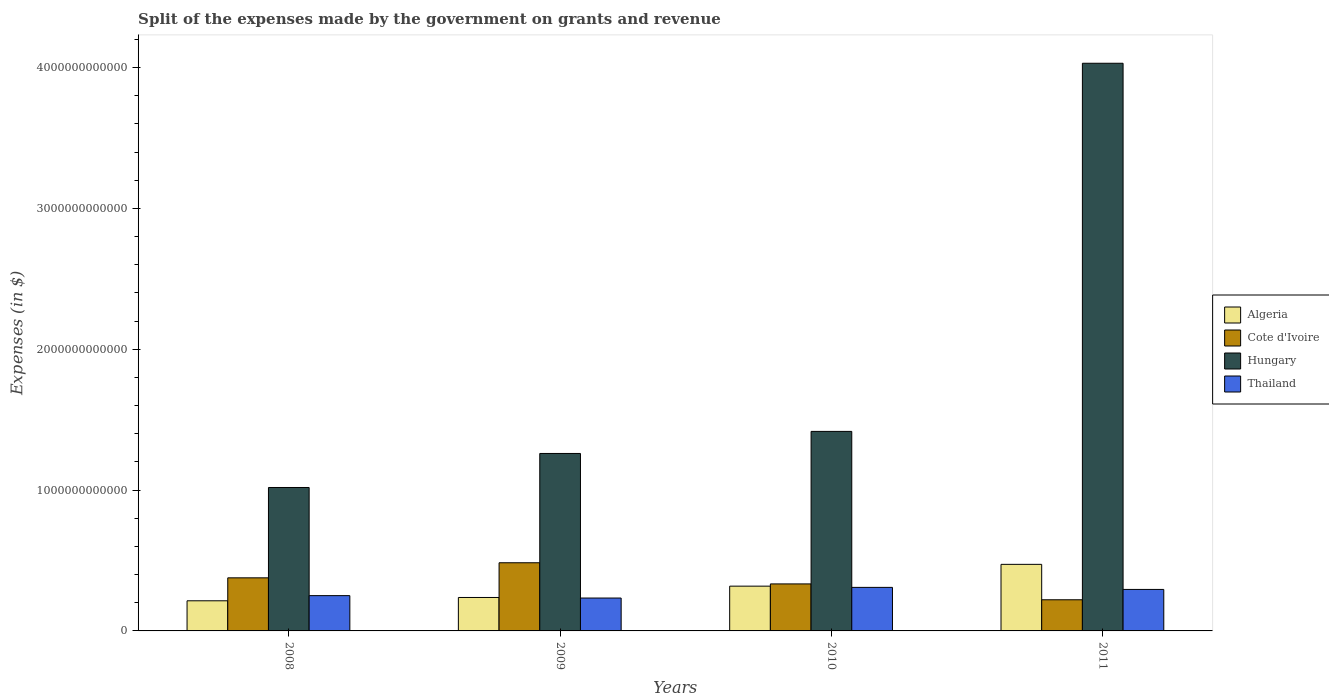How many different coloured bars are there?
Ensure brevity in your answer.  4. How many groups of bars are there?
Make the answer very short. 4. Are the number of bars on each tick of the X-axis equal?
Keep it short and to the point. Yes. How many bars are there on the 2nd tick from the left?
Ensure brevity in your answer.  4. What is the label of the 2nd group of bars from the left?
Make the answer very short. 2009. In how many cases, is the number of bars for a given year not equal to the number of legend labels?
Keep it short and to the point. 0. What is the expenses made by the government on grants and revenue in Thailand in 2010?
Offer a terse response. 3.09e+11. Across all years, what is the maximum expenses made by the government on grants and revenue in Algeria?
Provide a short and direct response. 4.73e+11. Across all years, what is the minimum expenses made by the government on grants and revenue in Cote d'Ivoire?
Provide a succinct answer. 2.21e+11. In which year was the expenses made by the government on grants and revenue in Algeria maximum?
Your answer should be very brief. 2011. In which year was the expenses made by the government on grants and revenue in Thailand minimum?
Provide a succinct answer. 2009. What is the total expenses made by the government on grants and revenue in Algeria in the graph?
Ensure brevity in your answer.  1.24e+12. What is the difference between the expenses made by the government on grants and revenue in Algeria in 2010 and that in 2011?
Your answer should be compact. -1.55e+11. What is the difference between the expenses made by the government on grants and revenue in Cote d'Ivoire in 2008 and the expenses made by the government on grants and revenue in Thailand in 2010?
Provide a succinct answer. 6.78e+1. What is the average expenses made by the government on grants and revenue in Thailand per year?
Provide a succinct answer. 2.72e+11. In the year 2008, what is the difference between the expenses made by the government on grants and revenue in Algeria and expenses made by the government on grants and revenue in Hungary?
Give a very brief answer. -8.04e+11. What is the ratio of the expenses made by the government on grants and revenue in Cote d'Ivoire in 2009 to that in 2011?
Keep it short and to the point. 2.19. Is the expenses made by the government on grants and revenue in Hungary in 2010 less than that in 2011?
Offer a terse response. Yes. Is the difference between the expenses made by the government on grants and revenue in Algeria in 2009 and 2011 greater than the difference between the expenses made by the government on grants and revenue in Hungary in 2009 and 2011?
Ensure brevity in your answer.  Yes. What is the difference between the highest and the second highest expenses made by the government on grants and revenue in Thailand?
Make the answer very short. 1.45e+1. What is the difference between the highest and the lowest expenses made by the government on grants and revenue in Algeria?
Give a very brief answer. 2.59e+11. Is the sum of the expenses made by the government on grants and revenue in Algeria in 2008 and 2010 greater than the maximum expenses made by the government on grants and revenue in Cote d'Ivoire across all years?
Your response must be concise. Yes. Is it the case that in every year, the sum of the expenses made by the government on grants and revenue in Thailand and expenses made by the government on grants and revenue in Hungary is greater than the sum of expenses made by the government on grants and revenue in Algeria and expenses made by the government on grants and revenue in Cote d'Ivoire?
Your answer should be very brief. No. What does the 2nd bar from the left in 2010 represents?
Offer a very short reply. Cote d'Ivoire. What does the 2nd bar from the right in 2009 represents?
Provide a succinct answer. Hungary. Is it the case that in every year, the sum of the expenses made by the government on grants and revenue in Algeria and expenses made by the government on grants and revenue in Cote d'Ivoire is greater than the expenses made by the government on grants and revenue in Thailand?
Provide a short and direct response. Yes. What is the difference between two consecutive major ticks on the Y-axis?
Make the answer very short. 1.00e+12. Are the values on the major ticks of Y-axis written in scientific E-notation?
Offer a terse response. No. Does the graph contain any zero values?
Ensure brevity in your answer.  No. Does the graph contain grids?
Ensure brevity in your answer.  No. How many legend labels are there?
Provide a short and direct response. 4. What is the title of the graph?
Offer a very short reply. Split of the expenses made by the government on grants and revenue. What is the label or title of the Y-axis?
Provide a succinct answer. Expenses (in $). What is the Expenses (in $) of Algeria in 2008?
Your answer should be compact. 2.14e+11. What is the Expenses (in $) in Cote d'Ivoire in 2008?
Make the answer very short. 3.77e+11. What is the Expenses (in $) in Hungary in 2008?
Give a very brief answer. 1.02e+12. What is the Expenses (in $) in Thailand in 2008?
Provide a short and direct response. 2.50e+11. What is the Expenses (in $) of Algeria in 2009?
Offer a very short reply. 2.37e+11. What is the Expenses (in $) in Cote d'Ivoire in 2009?
Ensure brevity in your answer.  4.84e+11. What is the Expenses (in $) of Hungary in 2009?
Offer a terse response. 1.26e+12. What is the Expenses (in $) of Thailand in 2009?
Give a very brief answer. 2.33e+11. What is the Expenses (in $) of Algeria in 2010?
Your answer should be very brief. 3.18e+11. What is the Expenses (in $) of Cote d'Ivoire in 2010?
Your answer should be compact. 3.34e+11. What is the Expenses (in $) of Hungary in 2010?
Provide a succinct answer. 1.42e+12. What is the Expenses (in $) of Thailand in 2010?
Provide a succinct answer. 3.09e+11. What is the Expenses (in $) in Algeria in 2011?
Ensure brevity in your answer.  4.73e+11. What is the Expenses (in $) in Cote d'Ivoire in 2011?
Make the answer very short. 2.21e+11. What is the Expenses (in $) in Hungary in 2011?
Provide a short and direct response. 4.03e+12. What is the Expenses (in $) of Thailand in 2011?
Your answer should be compact. 2.95e+11. Across all years, what is the maximum Expenses (in $) in Algeria?
Provide a succinct answer. 4.73e+11. Across all years, what is the maximum Expenses (in $) of Cote d'Ivoire?
Give a very brief answer. 4.84e+11. Across all years, what is the maximum Expenses (in $) of Hungary?
Provide a succinct answer. 4.03e+12. Across all years, what is the maximum Expenses (in $) in Thailand?
Ensure brevity in your answer.  3.09e+11. Across all years, what is the minimum Expenses (in $) of Algeria?
Your answer should be compact. 2.14e+11. Across all years, what is the minimum Expenses (in $) in Cote d'Ivoire?
Keep it short and to the point. 2.21e+11. Across all years, what is the minimum Expenses (in $) of Hungary?
Your answer should be very brief. 1.02e+12. Across all years, what is the minimum Expenses (in $) in Thailand?
Offer a very short reply. 2.33e+11. What is the total Expenses (in $) of Algeria in the graph?
Give a very brief answer. 1.24e+12. What is the total Expenses (in $) in Cote d'Ivoire in the graph?
Ensure brevity in your answer.  1.42e+12. What is the total Expenses (in $) of Hungary in the graph?
Keep it short and to the point. 7.72e+12. What is the total Expenses (in $) of Thailand in the graph?
Your answer should be compact. 1.09e+12. What is the difference between the Expenses (in $) of Algeria in 2008 and that in 2009?
Provide a short and direct response. -2.36e+1. What is the difference between the Expenses (in $) in Cote d'Ivoire in 2008 and that in 2009?
Your answer should be compact. -1.07e+11. What is the difference between the Expenses (in $) of Hungary in 2008 and that in 2009?
Offer a terse response. -2.42e+11. What is the difference between the Expenses (in $) of Thailand in 2008 and that in 2009?
Ensure brevity in your answer.  1.71e+1. What is the difference between the Expenses (in $) in Algeria in 2008 and that in 2010?
Make the answer very short. -1.04e+11. What is the difference between the Expenses (in $) of Cote d'Ivoire in 2008 and that in 2010?
Make the answer very short. 4.31e+1. What is the difference between the Expenses (in $) in Hungary in 2008 and that in 2010?
Your answer should be very brief. -3.98e+11. What is the difference between the Expenses (in $) of Thailand in 2008 and that in 2010?
Your answer should be very brief. -5.86e+1. What is the difference between the Expenses (in $) of Algeria in 2008 and that in 2011?
Offer a very short reply. -2.59e+11. What is the difference between the Expenses (in $) of Cote d'Ivoire in 2008 and that in 2011?
Your answer should be very brief. 1.56e+11. What is the difference between the Expenses (in $) in Hungary in 2008 and that in 2011?
Your answer should be compact. -3.01e+12. What is the difference between the Expenses (in $) in Thailand in 2008 and that in 2011?
Ensure brevity in your answer.  -4.41e+1. What is the difference between the Expenses (in $) of Algeria in 2009 and that in 2010?
Give a very brief answer. -8.04e+1. What is the difference between the Expenses (in $) in Cote d'Ivoire in 2009 and that in 2010?
Your answer should be very brief. 1.50e+11. What is the difference between the Expenses (in $) of Hungary in 2009 and that in 2010?
Keep it short and to the point. -1.57e+11. What is the difference between the Expenses (in $) in Thailand in 2009 and that in 2010?
Your response must be concise. -7.57e+1. What is the difference between the Expenses (in $) of Algeria in 2009 and that in 2011?
Offer a very short reply. -2.35e+11. What is the difference between the Expenses (in $) of Cote d'Ivoire in 2009 and that in 2011?
Offer a terse response. 2.63e+11. What is the difference between the Expenses (in $) of Hungary in 2009 and that in 2011?
Make the answer very short. -2.77e+12. What is the difference between the Expenses (in $) of Thailand in 2009 and that in 2011?
Your response must be concise. -6.11e+1. What is the difference between the Expenses (in $) of Algeria in 2010 and that in 2011?
Keep it short and to the point. -1.55e+11. What is the difference between the Expenses (in $) of Cote d'Ivoire in 2010 and that in 2011?
Give a very brief answer. 1.13e+11. What is the difference between the Expenses (in $) in Hungary in 2010 and that in 2011?
Provide a short and direct response. -2.61e+12. What is the difference between the Expenses (in $) of Thailand in 2010 and that in 2011?
Give a very brief answer. 1.45e+1. What is the difference between the Expenses (in $) in Algeria in 2008 and the Expenses (in $) in Cote d'Ivoire in 2009?
Give a very brief answer. -2.70e+11. What is the difference between the Expenses (in $) of Algeria in 2008 and the Expenses (in $) of Hungary in 2009?
Your answer should be compact. -1.05e+12. What is the difference between the Expenses (in $) in Algeria in 2008 and the Expenses (in $) in Thailand in 2009?
Your answer should be very brief. -1.95e+1. What is the difference between the Expenses (in $) of Cote d'Ivoire in 2008 and the Expenses (in $) of Hungary in 2009?
Your response must be concise. -8.83e+11. What is the difference between the Expenses (in $) in Cote d'Ivoire in 2008 and the Expenses (in $) in Thailand in 2009?
Provide a short and direct response. 1.43e+11. What is the difference between the Expenses (in $) in Hungary in 2008 and the Expenses (in $) in Thailand in 2009?
Make the answer very short. 7.85e+11. What is the difference between the Expenses (in $) of Algeria in 2008 and the Expenses (in $) of Cote d'Ivoire in 2010?
Your answer should be compact. -1.20e+11. What is the difference between the Expenses (in $) of Algeria in 2008 and the Expenses (in $) of Hungary in 2010?
Ensure brevity in your answer.  -1.20e+12. What is the difference between the Expenses (in $) in Algeria in 2008 and the Expenses (in $) in Thailand in 2010?
Offer a terse response. -9.52e+1. What is the difference between the Expenses (in $) of Cote d'Ivoire in 2008 and the Expenses (in $) of Hungary in 2010?
Offer a very short reply. -1.04e+12. What is the difference between the Expenses (in $) of Cote d'Ivoire in 2008 and the Expenses (in $) of Thailand in 2010?
Ensure brevity in your answer.  6.78e+1. What is the difference between the Expenses (in $) in Hungary in 2008 and the Expenses (in $) in Thailand in 2010?
Offer a terse response. 7.09e+11. What is the difference between the Expenses (in $) of Algeria in 2008 and the Expenses (in $) of Cote d'Ivoire in 2011?
Your answer should be compact. -7.29e+09. What is the difference between the Expenses (in $) in Algeria in 2008 and the Expenses (in $) in Hungary in 2011?
Give a very brief answer. -3.82e+12. What is the difference between the Expenses (in $) of Algeria in 2008 and the Expenses (in $) of Thailand in 2011?
Ensure brevity in your answer.  -8.07e+1. What is the difference between the Expenses (in $) in Cote d'Ivoire in 2008 and the Expenses (in $) in Hungary in 2011?
Ensure brevity in your answer.  -3.65e+12. What is the difference between the Expenses (in $) in Cote d'Ivoire in 2008 and the Expenses (in $) in Thailand in 2011?
Make the answer very short. 8.23e+1. What is the difference between the Expenses (in $) of Hungary in 2008 and the Expenses (in $) of Thailand in 2011?
Ensure brevity in your answer.  7.24e+11. What is the difference between the Expenses (in $) in Algeria in 2009 and the Expenses (in $) in Cote d'Ivoire in 2010?
Offer a very short reply. -9.63e+1. What is the difference between the Expenses (in $) of Algeria in 2009 and the Expenses (in $) of Hungary in 2010?
Your answer should be compact. -1.18e+12. What is the difference between the Expenses (in $) in Algeria in 2009 and the Expenses (in $) in Thailand in 2010?
Provide a short and direct response. -7.16e+1. What is the difference between the Expenses (in $) in Cote d'Ivoire in 2009 and the Expenses (in $) in Hungary in 2010?
Offer a terse response. -9.33e+11. What is the difference between the Expenses (in $) of Cote d'Ivoire in 2009 and the Expenses (in $) of Thailand in 2010?
Your answer should be very brief. 1.75e+11. What is the difference between the Expenses (in $) in Hungary in 2009 and the Expenses (in $) in Thailand in 2010?
Your answer should be very brief. 9.51e+11. What is the difference between the Expenses (in $) in Algeria in 2009 and the Expenses (in $) in Cote d'Ivoire in 2011?
Your response must be concise. 1.63e+1. What is the difference between the Expenses (in $) of Algeria in 2009 and the Expenses (in $) of Hungary in 2011?
Your answer should be compact. -3.79e+12. What is the difference between the Expenses (in $) in Algeria in 2009 and the Expenses (in $) in Thailand in 2011?
Provide a succinct answer. -5.71e+1. What is the difference between the Expenses (in $) in Cote d'Ivoire in 2009 and the Expenses (in $) in Hungary in 2011?
Keep it short and to the point. -3.55e+12. What is the difference between the Expenses (in $) in Cote d'Ivoire in 2009 and the Expenses (in $) in Thailand in 2011?
Your response must be concise. 1.89e+11. What is the difference between the Expenses (in $) in Hungary in 2009 and the Expenses (in $) in Thailand in 2011?
Make the answer very short. 9.65e+11. What is the difference between the Expenses (in $) in Algeria in 2010 and the Expenses (in $) in Cote d'Ivoire in 2011?
Your answer should be very brief. 9.67e+1. What is the difference between the Expenses (in $) in Algeria in 2010 and the Expenses (in $) in Hungary in 2011?
Provide a succinct answer. -3.71e+12. What is the difference between the Expenses (in $) in Algeria in 2010 and the Expenses (in $) in Thailand in 2011?
Offer a terse response. 2.33e+1. What is the difference between the Expenses (in $) in Cote d'Ivoire in 2010 and the Expenses (in $) in Hungary in 2011?
Provide a succinct answer. -3.70e+12. What is the difference between the Expenses (in $) in Cote d'Ivoire in 2010 and the Expenses (in $) in Thailand in 2011?
Keep it short and to the point. 3.92e+1. What is the difference between the Expenses (in $) in Hungary in 2010 and the Expenses (in $) in Thailand in 2011?
Keep it short and to the point. 1.12e+12. What is the average Expenses (in $) of Algeria per year?
Give a very brief answer. 3.10e+11. What is the average Expenses (in $) in Cote d'Ivoire per year?
Offer a terse response. 3.54e+11. What is the average Expenses (in $) in Hungary per year?
Make the answer very short. 1.93e+12. What is the average Expenses (in $) in Thailand per year?
Offer a very short reply. 2.72e+11. In the year 2008, what is the difference between the Expenses (in $) of Algeria and Expenses (in $) of Cote d'Ivoire?
Offer a terse response. -1.63e+11. In the year 2008, what is the difference between the Expenses (in $) in Algeria and Expenses (in $) in Hungary?
Offer a terse response. -8.04e+11. In the year 2008, what is the difference between the Expenses (in $) of Algeria and Expenses (in $) of Thailand?
Make the answer very short. -3.66e+1. In the year 2008, what is the difference between the Expenses (in $) in Cote d'Ivoire and Expenses (in $) in Hungary?
Ensure brevity in your answer.  -6.41e+11. In the year 2008, what is the difference between the Expenses (in $) in Cote d'Ivoire and Expenses (in $) in Thailand?
Provide a succinct answer. 1.26e+11. In the year 2008, what is the difference between the Expenses (in $) of Hungary and Expenses (in $) of Thailand?
Your response must be concise. 7.68e+11. In the year 2009, what is the difference between the Expenses (in $) of Algeria and Expenses (in $) of Cote d'Ivoire?
Provide a short and direct response. -2.47e+11. In the year 2009, what is the difference between the Expenses (in $) of Algeria and Expenses (in $) of Hungary?
Keep it short and to the point. -1.02e+12. In the year 2009, what is the difference between the Expenses (in $) in Algeria and Expenses (in $) in Thailand?
Keep it short and to the point. 4.04e+09. In the year 2009, what is the difference between the Expenses (in $) of Cote d'Ivoire and Expenses (in $) of Hungary?
Offer a terse response. -7.76e+11. In the year 2009, what is the difference between the Expenses (in $) in Cote d'Ivoire and Expenses (in $) in Thailand?
Your answer should be very brief. 2.51e+11. In the year 2009, what is the difference between the Expenses (in $) in Hungary and Expenses (in $) in Thailand?
Give a very brief answer. 1.03e+12. In the year 2010, what is the difference between the Expenses (in $) in Algeria and Expenses (in $) in Cote d'Ivoire?
Provide a short and direct response. -1.59e+1. In the year 2010, what is the difference between the Expenses (in $) of Algeria and Expenses (in $) of Hungary?
Provide a succinct answer. -1.10e+12. In the year 2010, what is the difference between the Expenses (in $) of Algeria and Expenses (in $) of Thailand?
Provide a short and direct response. 8.81e+09. In the year 2010, what is the difference between the Expenses (in $) of Cote d'Ivoire and Expenses (in $) of Hungary?
Keep it short and to the point. -1.08e+12. In the year 2010, what is the difference between the Expenses (in $) in Cote d'Ivoire and Expenses (in $) in Thailand?
Offer a terse response. 2.47e+1. In the year 2010, what is the difference between the Expenses (in $) in Hungary and Expenses (in $) in Thailand?
Offer a very short reply. 1.11e+12. In the year 2011, what is the difference between the Expenses (in $) in Algeria and Expenses (in $) in Cote d'Ivoire?
Your response must be concise. 2.51e+11. In the year 2011, what is the difference between the Expenses (in $) of Algeria and Expenses (in $) of Hungary?
Ensure brevity in your answer.  -3.56e+12. In the year 2011, what is the difference between the Expenses (in $) of Algeria and Expenses (in $) of Thailand?
Offer a very short reply. 1.78e+11. In the year 2011, what is the difference between the Expenses (in $) in Cote d'Ivoire and Expenses (in $) in Hungary?
Your response must be concise. -3.81e+12. In the year 2011, what is the difference between the Expenses (in $) of Cote d'Ivoire and Expenses (in $) of Thailand?
Your response must be concise. -7.34e+1. In the year 2011, what is the difference between the Expenses (in $) in Hungary and Expenses (in $) in Thailand?
Provide a succinct answer. 3.74e+12. What is the ratio of the Expenses (in $) in Algeria in 2008 to that in 2009?
Offer a terse response. 0.9. What is the ratio of the Expenses (in $) in Cote d'Ivoire in 2008 to that in 2009?
Keep it short and to the point. 0.78. What is the ratio of the Expenses (in $) in Hungary in 2008 to that in 2009?
Provide a succinct answer. 0.81. What is the ratio of the Expenses (in $) in Thailand in 2008 to that in 2009?
Keep it short and to the point. 1.07. What is the ratio of the Expenses (in $) in Algeria in 2008 to that in 2010?
Provide a succinct answer. 0.67. What is the ratio of the Expenses (in $) of Cote d'Ivoire in 2008 to that in 2010?
Your answer should be very brief. 1.13. What is the ratio of the Expenses (in $) in Hungary in 2008 to that in 2010?
Your response must be concise. 0.72. What is the ratio of the Expenses (in $) of Thailand in 2008 to that in 2010?
Provide a short and direct response. 0.81. What is the ratio of the Expenses (in $) in Algeria in 2008 to that in 2011?
Keep it short and to the point. 0.45. What is the ratio of the Expenses (in $) in Cote d'Ivoire in 2008 to that in 2011?
Offer a terse response. 1.7. What is the ratio of the Expenses (in $) of Hungary in 2008 to that in 2011?
Offer a very short reply. 0.25. What is the ratio of the Expenses (in $) of Thailand in 2008 to that in 2011?
Provide a short and direct response. 0.85. What is the ratio of the Expenses (in $) in Algeria in 2009 to that in 2010?
Offer a very short reply. 0.75. What is the ratio of the Expenses (in $) of Cote d'Ivoire in 2009 to that in 2010?
Make the answer very short. 1.45. What is the ratio of the Expenses (in $) in Hungary in 2009 to that in 2010?
Your response must be concise. 0.89. What is the ratio of the Expenses (in $) in Thailand in 2009 to that in 2010?
Give a very brief answer. 0.76. What is the ratio of the Expenses (in $) of Algeria in 2009 to that in 2011?
Your response must be concise. 0.5. What is the ratio of the Expenses (in $) in Cote d'Ivoire in 2009 to that in 2011?
Provide a succinct answer. 2.19. What is the ratio of the Expenses (in $) in Hungary in 2009 to that in 2011?
Your response must be concise. 0.31. What is the ratio of the Expenses (in $) in Thailand in 2009 to that in 2011?
Offer a very short reply. 0.79. What is the ratio of the Expenses (in $) of Algeria in 2010 to that in 2011?
Your answer should be compact. 0.67. What is the ratio of the Expenses (in $) of Cote d'Ivoire in 2010 to that in 2011?
Your response must be concise. 1.51. What is the ratio of the Expenses (in $) of Hungary in 2010 to that in 2011?
Provide a succinct answer. 0.35. What is the ratio of the Expenses (in $) in Thailand in 2010 to that in 2011?
Your response must be concise. 1.05. What is the difference between the highest and the second highest Expenses (in $) in Algeria?
Provide a short and direct response. 1.55e+11. What is the difference between the highest and the second highest Expenses (in $) in Cote d'Ivoire?
Give a very brief answer. 1.07e+11. What is the difference between the highest and the second highest Expenses (in $) of Hungary?
Offer a very short reply. 2.61e+12. What is the difference between the highest and the second highest Expenses (in $) of Thailand?
Your answer should be very brief. 1.45e+1. What is the difference between the highest and the lowest Expenses (in $) in Algeria?
Provide a succinct answer. 2.59e+11. What is the difference between the highest and the lowest Expenses (in $) in Cote d'Ivoire?
Make the answer very short. 2.63e+11. What is the difference between the highest and the lowest Expenses (in $) of Hungary?
Give a very brief answer. 3.01e+12. What is the difference between the highest and the lowest Expenses (in $) in Thailand?
Offer a terse response. 7.57e+1. 